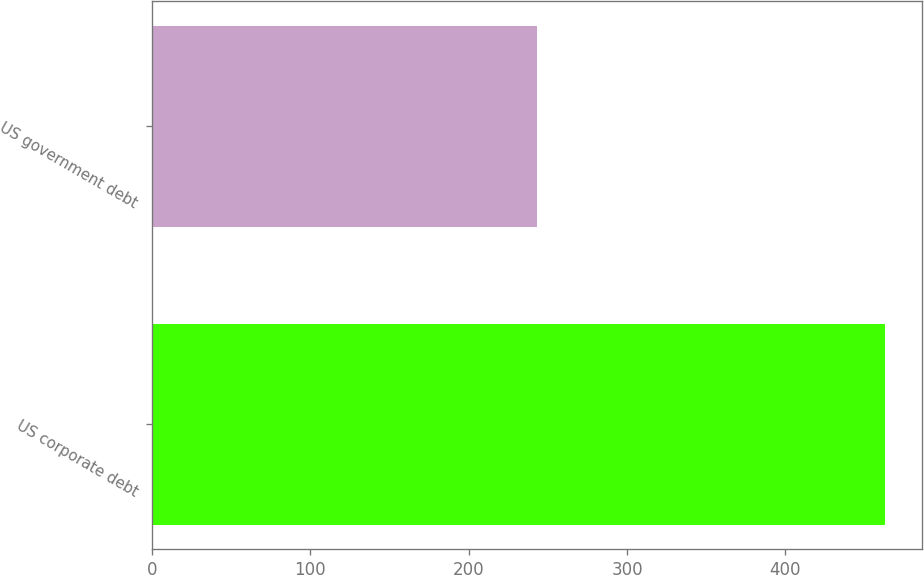Convert chart. <chart><loc_0><loc_0><loc_500><loc_500><bar_chart><fcel>US corporate debt<fcel>US government debt<nl><fcel>463<fcel>243<nl></chart> 